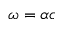Convert formula to latex. <formula><loc_0><loc_0><loc_500><loc_500>\omega = \alpha c</formula> 